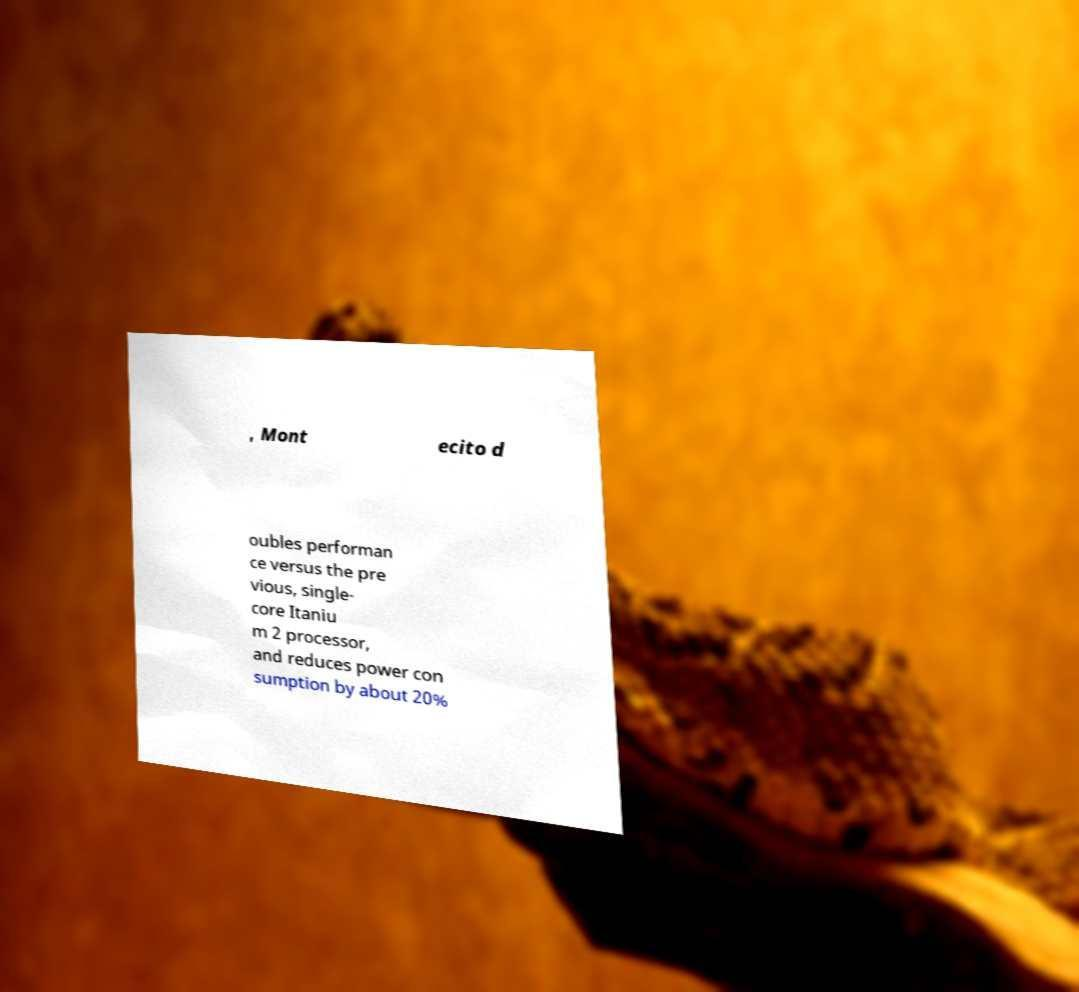Can you read and provide the text displayed in the image?This photo seems to have some interesting text. Can you extract and type it out for me? , Mont ecito d oubles performan ce versus the pre vious, single- core Itaniu m 2 processor, and reduces power con sumption by about 20% 